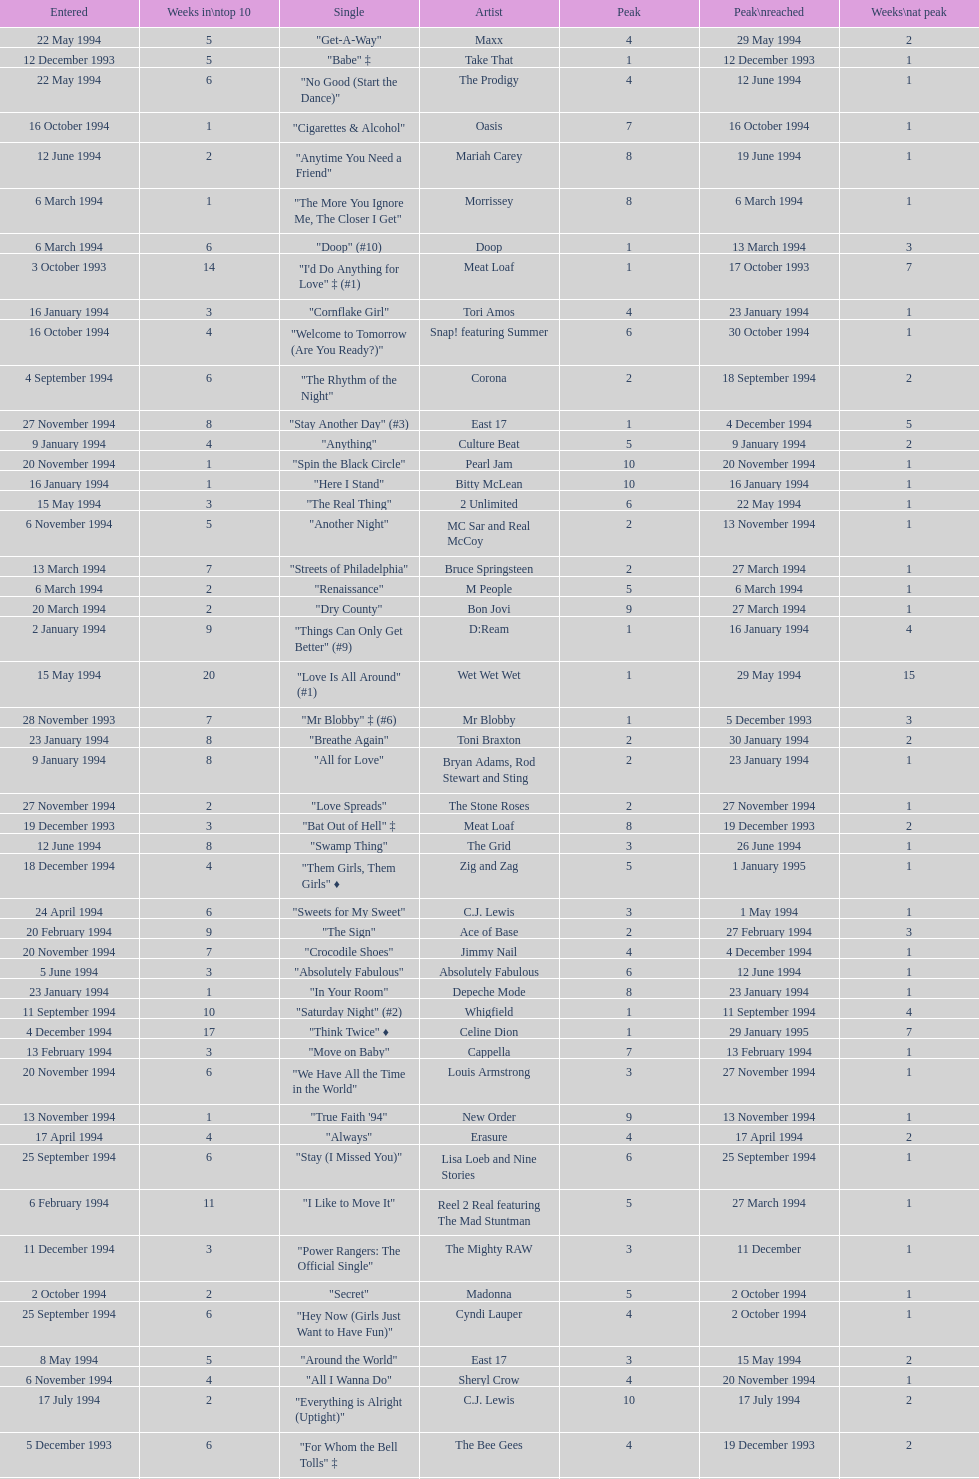Which artist only has its single entered on 2 january 1994? D:Ream. 